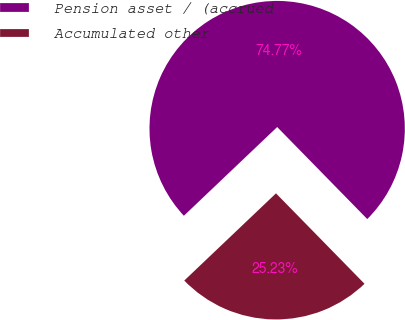Convert chart. <chart><loc_0><loc_0><loc_500><loc_500><pie_chart><fcel>Pension asset / (accrued<fcel>Accumulated other<nl><fcel>74.77%<fcel>25.23%<nl></chart> 